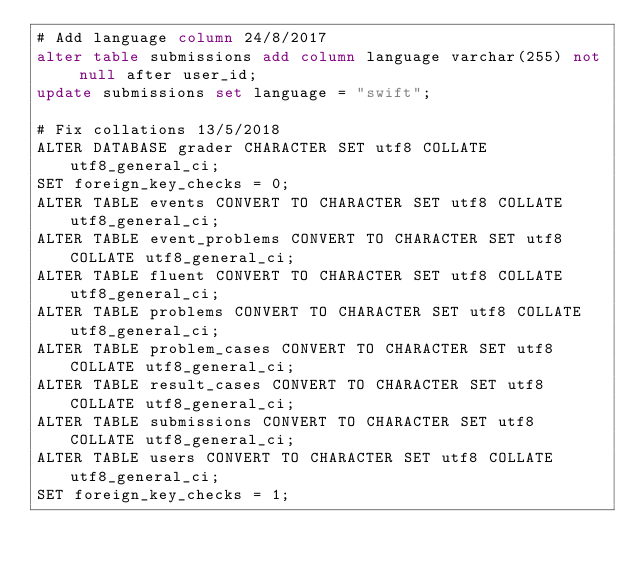Convert code to text. <code><loc_0><loc_0><loc_500><loc_500><_SQL_># Add language column 24/8/2017
alter table submissions add column language varchar(255) not null after user_id;
update submissions set language = "swift";

# Fix collations 13/5/2018
ALTER DATABASE grader CHARACTER SET utf8 COLLATE utf8_general_ci;
SET foreign_key_checks = 0;
ALTER TABLE events CONVERT TO CHARACTER SET utf8 COLLATE utf8_general_ci;
ALTER TABLE event_problems CONVERT TO CHARACTER SET utf8 COLLATE utf8_general_ci;
ALTER TABLE fluent CONVERT TO CHARACTER SET utf8 COLLATE utf8_general_ci;
ALTER TABLE problems CONVERT TO CHARACTER SET utf8 COLLATE utf8_general_ci;
ALTER TABLE problem_cases CONVERT TO CHARACTER SET utf8 COLLATE utf8_general_ci;
ALTER TABLE result_cases CONVERT TO CHARACTER SET utf8 COLLATE utf8_general_ci;
ALTER TABLE submissions CONVERT TO CHARACTER SET utf8 COLLATE utf8_general_ci;
ALTER TABLE users CONVERT TO CHARACTER SET utf8 COLLATE utf8_general_ci;
SET foreign_key_checks = 1;
</code> 